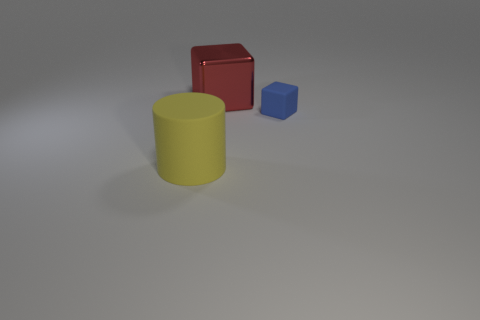Add 3 big red metal things. How many objects exist? 6 Subtract all blocks. How many objects are left? 1 Add 2 big red shiny cubes. How many big red shiny cubes are left? 3 Add 1 big shiny objects. How many big shiny objects exist? 2 Subtract 0 blue balls. How many objects are left? 3 Subtract all small green blocks. Subtract all small blue things. How many objects are left? 2 